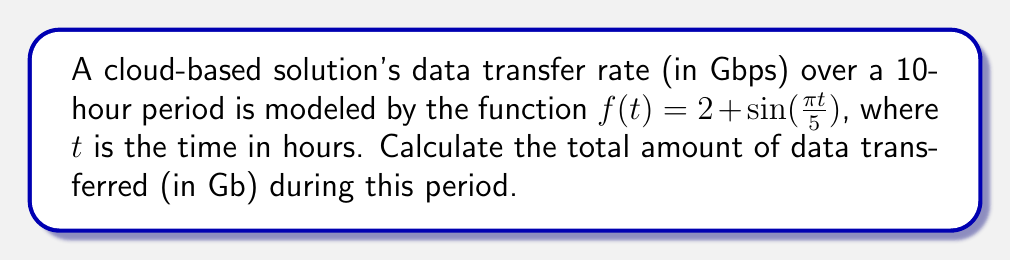Help me with this question. To solve this problem, we need to find the area under the curve of $f(t)$ from $t=0$ to $t=10$. This can be done using definite integration:

1) The total data transferred is given by the integral:
   $$\int_0^{10} f(t) dt = \int_0^{10} (2 + \sin(\frac{\pi t}{5})) dt$$

2) Let's integrate this function:
   $$\int (2 + \sin(\frac{\pi t}{5})) dt = 2t - \frac{5}{\pi} \cos(\frac{\pi t}{5}) + C$$

3) Now, we apply the limits:
   $$\left[2t - \frac{5}{\pi} \cos(\frac{\pi t}{5})\right]_0^{10}$$

4) Evaluate at $t=10$:
   $$2(10) - \frac{5}{\pi} \cos(\frac{\pi (10)}{5}) = 20 - \frac{5}{\pi} \cos(2\pi) = 20 - \frac{5}{\pi}$$

5) Evaluate at $t=0$:
   $$2(0) - \frac{5}{\pi} \cos(\frac{\pi (0)}{5}) = 0 - \frac{5}{\pi}$$

6) Subtract the results:
   $$(20 - \frac{5}{\pi}) - (0 - \frac{5}{\pi}) = 20$$

7) The result, 20, represents the area under the curve in Gbps * hours. To convert to Gb, we multiply by 3600 (seconds per hour):
   $$20 * 3600 = 72000 \text{ Gb}$$
Answer: 72000 Gb 